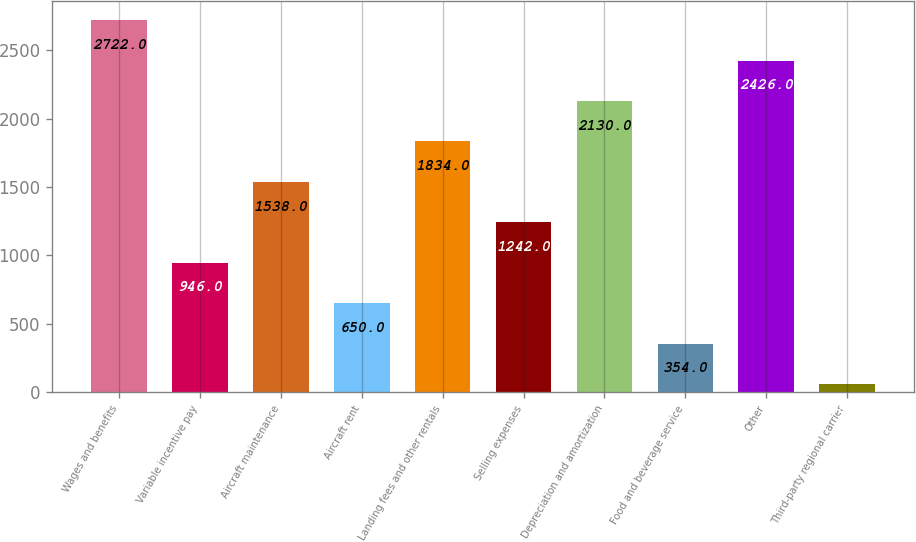<chart> <loc_0><loc_0><loc_500><loc_500><bar_chart><fcel>Wages and benefits<fcel>Variable incentive pay<fcel>Aircraft maintenance<fcel>Aircraft rent<fcel>Landing fees and other rentals<fcel>Selling expenses<fcel>Depreciation and amortization<fcel>Food and beverage service<fcel>Other<fcel>Third-party regional carrier<nl><fcel>2722<fcel>946<fcel>1538<fcel>650<fcel>1834<fcel>1242<fcel>2130<fcel>354<fcel>2426<fcel>58<nl></chart> 